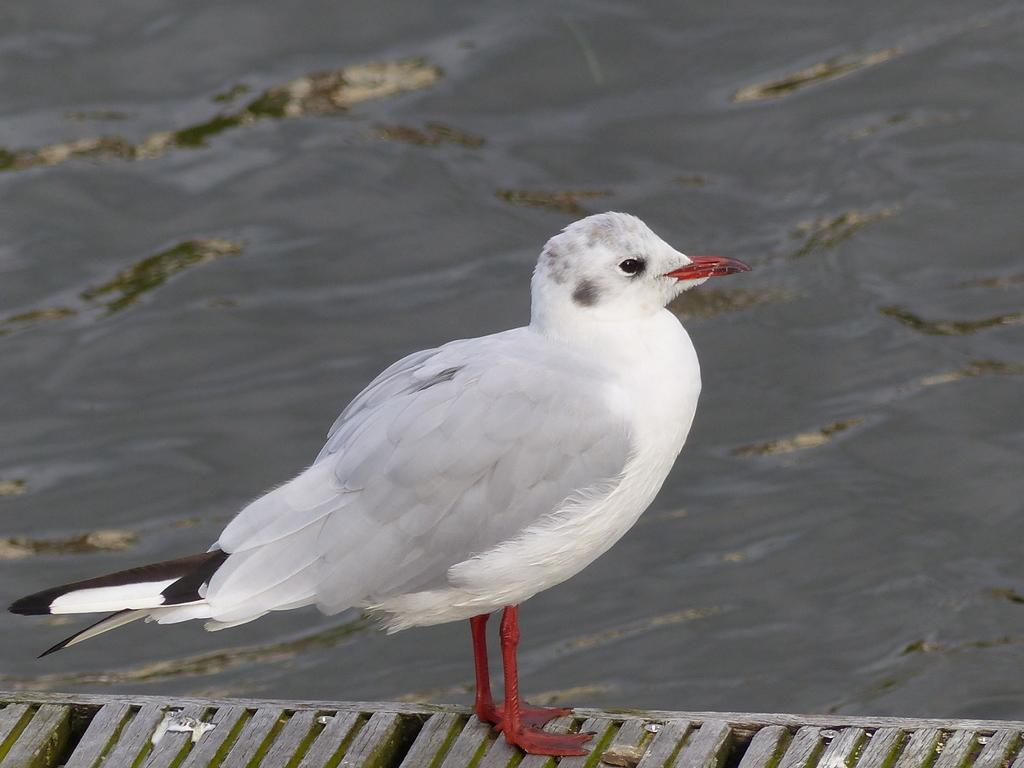What type of animal can be seen in the image? There is a bird in the image. What is visible in the image besides the bird? There is water visible in the image. What type of baseball equipment can be seen in the image? There is no baseball equipment present in the image. What type of fire can be seen in the image? There is no fire present in the image. What type of air can be seen in the image? There is no specific type of air present in the image; it is simply the atmosphere surrounding the bird and water. 